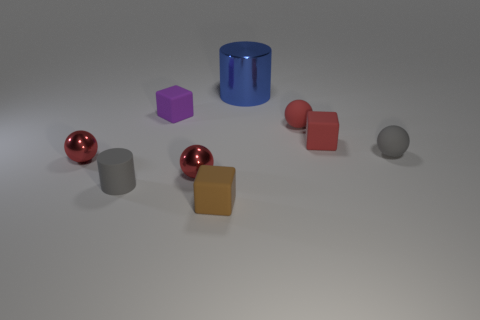There is a gray ball that is the same size as the brown thing; what is it made of?
Provide a short and direct response. Rubber. Are the big object and the small brown object made of the same material?
Your answer should be compact. No. The gray thing on the right side of the brown rubber cube has what shape?
Keep it short and to the point. Sphere. There is another ball that is the same material as the small gray sphere; what is its color?
Offer a terse response. Red. There is a ball that is on the left side of the tiny brown object and on the right side of the tiny rubber cylinder; what is it made of?
Provide a short and direct response. Metal. The brown object that is made of the same material as the gray ball is what shape?
Keep it short and to the point. Cube. The red block that is made of the same material as the gray ball is what size?
Provide a short and direct response. Small. The metal object that is to the right of the purple block and in front of the large blue metal object has what shape?
Provide a succinct answer. Sphere. What is the size of the red metallic sphere to the right of the gray thing that is left of the big object?
Provide a succinct answer. Small. What number of other things are there of the same color as the small cylinder?
Ensure brevity in your answer.  1. 